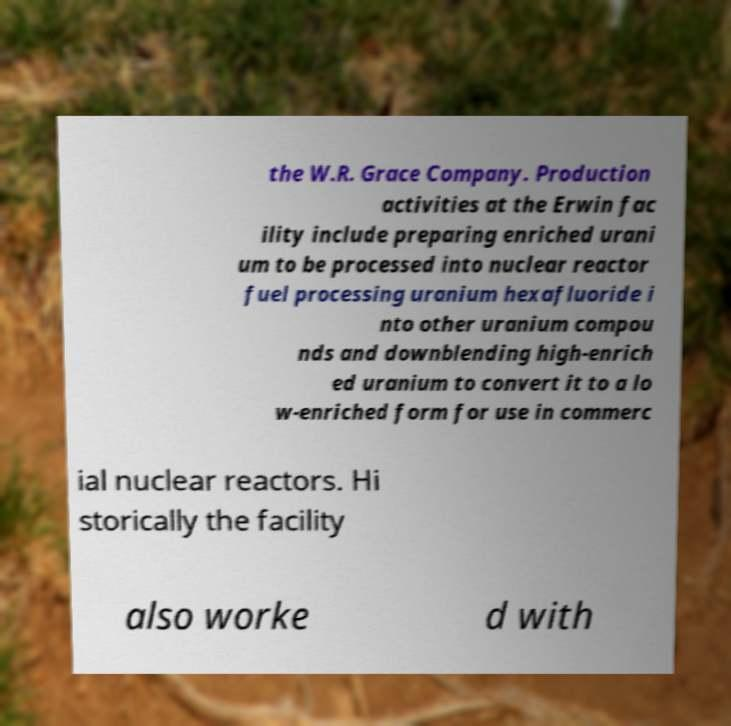There's text embedded in this image that I need extracted. Can you transcribe it verbatim? the W.R. Grace Company. Production activities at the Erwin fac ility include preparing enriched urani um to be processed into nuclear reactor fuel processing uranium hexafluoride i nto other uranium compou nds and downblending high-enrich ed uranium to convert it to a lo w-enriched form for use in commerc ial nuclear reactors. Hi storically the facility also worke d with 